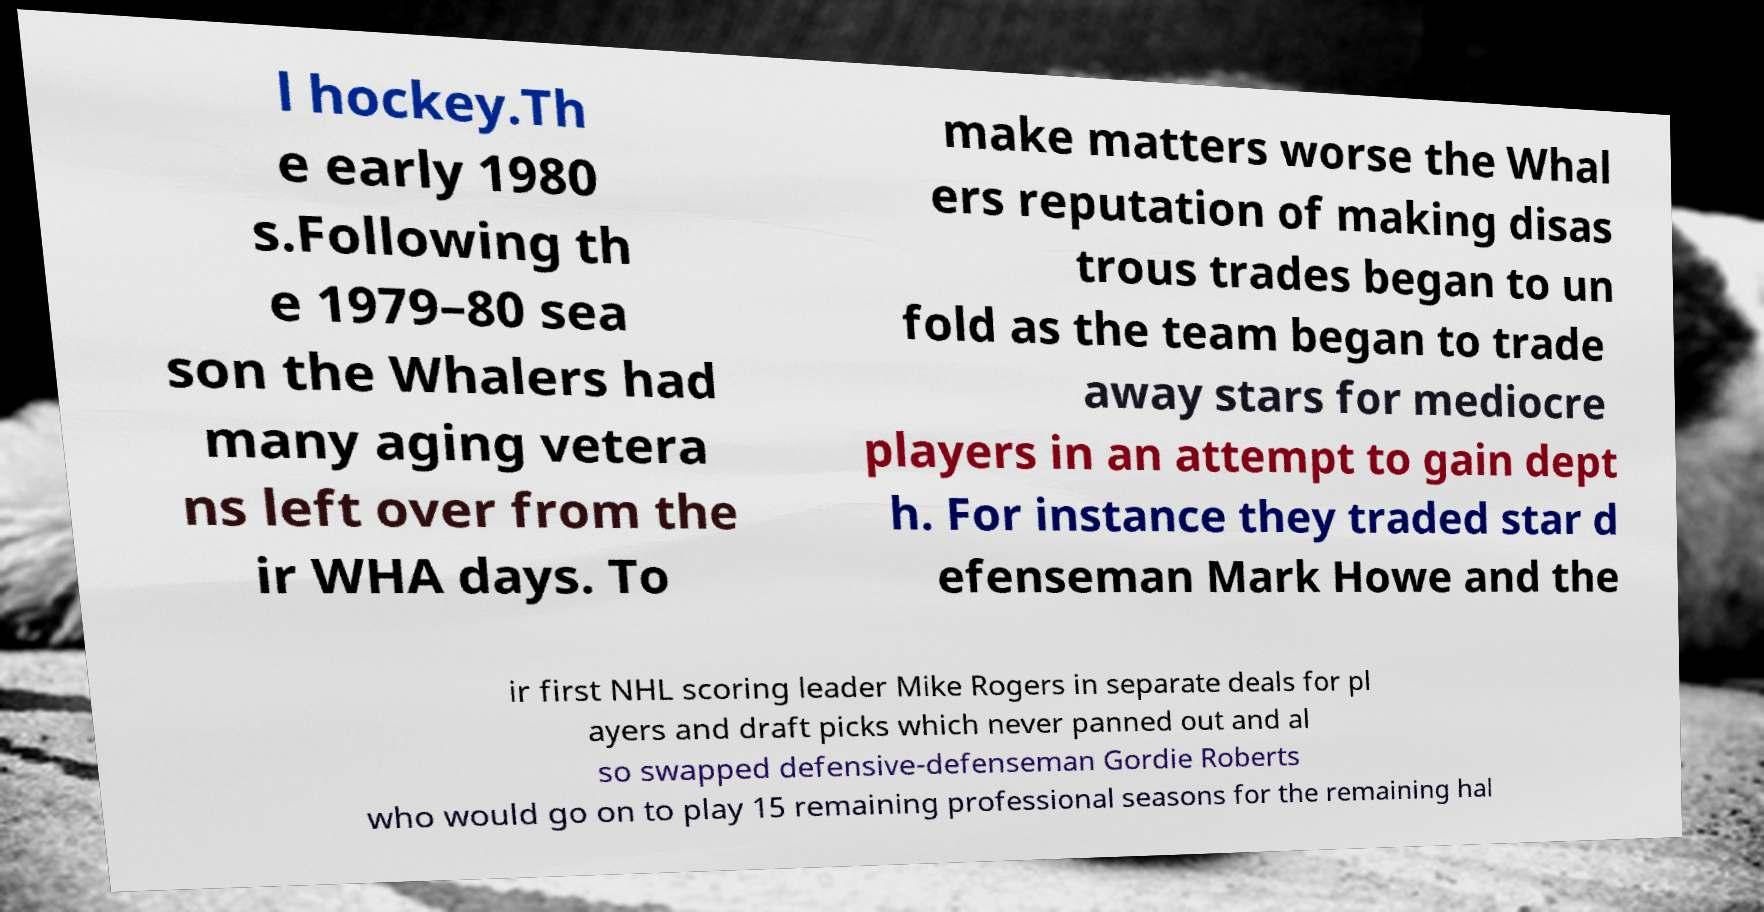Can you read and provide the text displayed in the image?This photo seems to have some interesting text. Can you extract and type it out for me? l hockey.Th e early 1980 s.Following th e 1979–80 sea son the Whalers had many aging vetera ns left over from the ir WHA days. To make matters worse the Whal ers reputation of making disas trous trades began to un fold as the team began to trade away stars for mediocre players in an attempt to gain dept h. For instance they traded star d efenseman Mark Howe and the ir first NHL scoring leader Mike Rogers in separate deals for pl ayers and draft picks which never panned out and al so swapped defensive-defenseman Gordie Roberts who would go on to play 15 remaining professional seasons for the remaining hal 